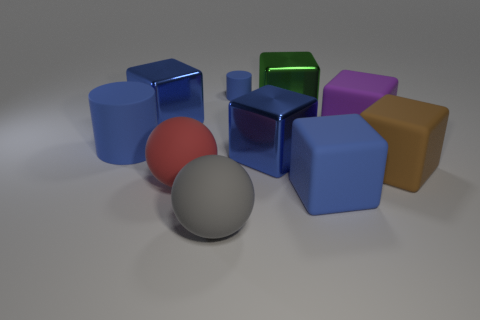Subtract all gray cylinders. How many blue blocks are left? 3 Subtract all green blocks. How many blocks are left? 5 Subtract all purple matte cubes. How many cubes are left? 5 Subtract all yellow cubes. Subtract all cyan balls. How many cubes are left? 6 Subtract all cubes. How many objects are left? 4 Subtract all purple blocks. Subtract all big shiny blocks. How many objects are left? 6 Add 7 blue shiny things. How many blue shiny things are left? 9 Add 2 large brown balls. How many large brown balls exist? 2 Subtract 1 purple blocks. How many objects are left? 9 